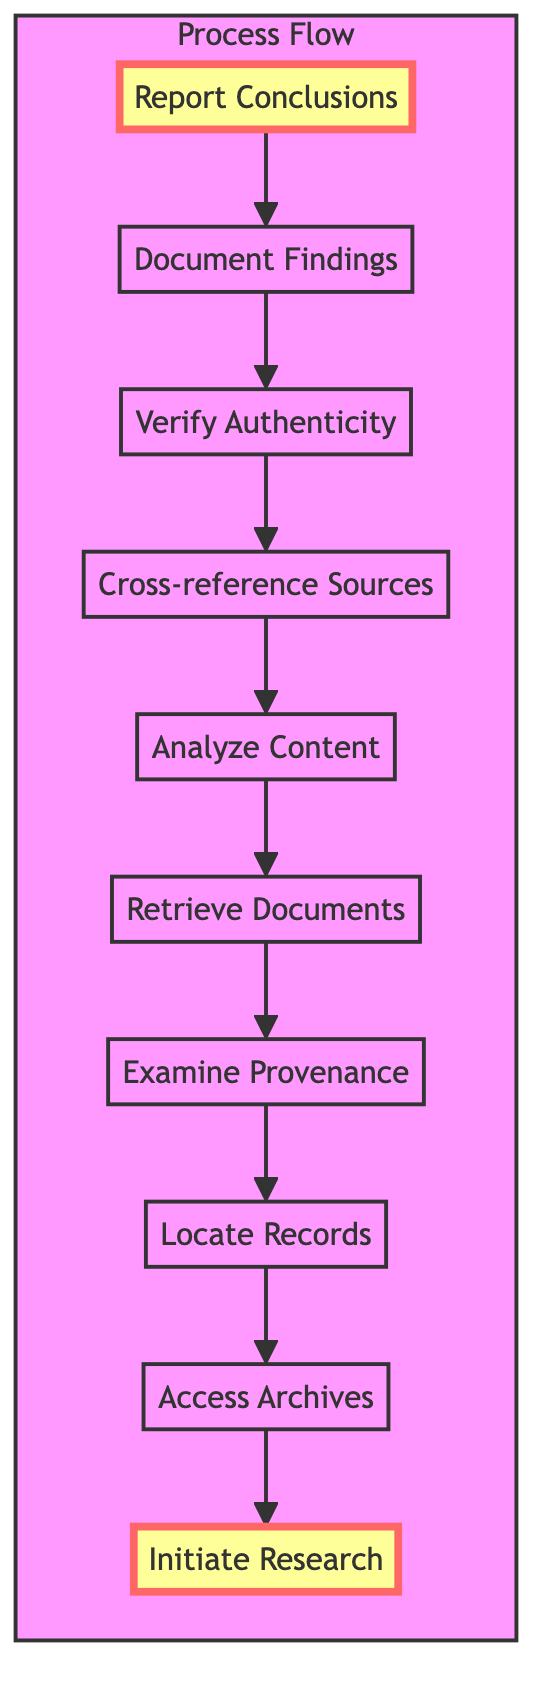What is the first step in the process? The diagram indicates that the first step is "Initiate Research", which is the topmost node of the flowchart.
Answer: Initiate Research How many total steps are in the flowchart? By counting the nodes in the flowchart, there are a total of ten distinct steps from "Initiate Research" to "Report Conclusions".
Answer: 10 Which step comes immediately after "Retrieve Documents"? Following the directional arrows in the flowchart, "Analyze Content" is the step that comes immediately after "Retrieve Documents."
Answer: Analyze Content What is the last step in the analysis process? The flowchart shows that the final step is "Report Conclusions," which is the bottom-most node.
Answer: Report Conclusions Which step involves checking the credibility of the documents? The step "Verify Authenticity" is specifically focused on assessing the credibility of the documents in the analysis process.
Answer: Verify Authenticity What two steps are directly connected to "Cross-reference Sources"? The diagram shows that "Cross-reference Sources" connects directly with "Analyze Content" before it and "Verify Authenticity" after it.
Answer: Analyze Content and Verify Authenticity What happens following "Examine Provenance"? From the flow layout, "Retrieve Documents" is the next step that follows "Examine Provenance."
Answer: Retrieve Documents What is the relationship between "Access Archives" and "Locate Records"? According to the flowchart, "Access Archives" is a prerequisite step that leads into "Locate Records," indicating that access must be gained before records can be located.
Answer: Prerequisite What function does "Document Findings" serve in the analysis? The step "Document Findings" is crucial for recording and ensuring proper citation of the research findings, summarizing the essential information derived from the analyzed records.
Answer: Documenting findings List the two steps that immediately follow "Analyze Content". The direct subsequent steps from "Analyze Content" are "Cross-reference Sources" and then "Verify Authenticity" as indicated by the arrows leading out from "Analyze Content."
Answer: Cross-reference Sources and Verify Authenticity 